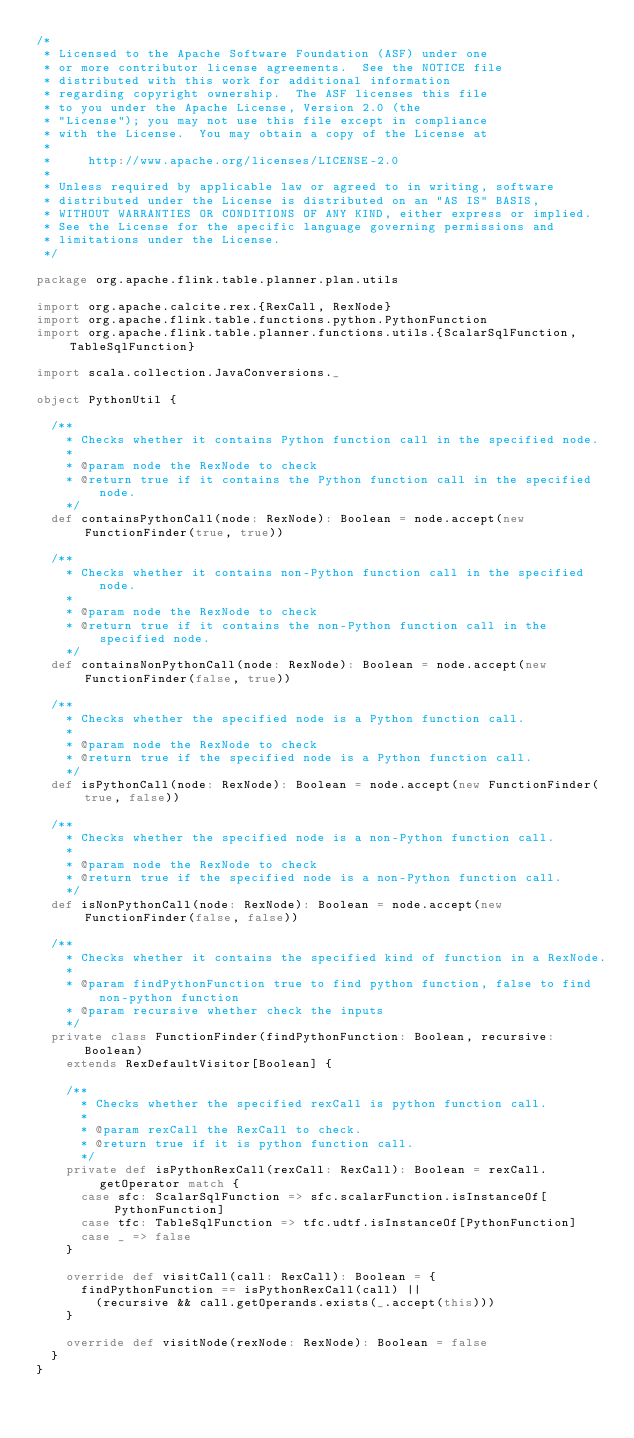<code> <loc_0><loc_0><loc_500><loc_500><_Scala_>/*
 * Licensed to the Apache Software Foundation (ASF) under one
 * or more contributor license agreements.  See the NOTICE file
 * distributed with this work for additional information
 * regarding copyright ownership.  The ASF licenses this file
 * to you under the Apache License, Version 2.0 (the
 * "License"); you may not use this file except in compliance
 * with the License.  You may obtain a copy of the License at
 *
 *     http://www.apache.org/licenses/LICENSE-2.0
 *
 * Unless required by applicable law or agreed to in writing, software
 * distributed under the License is distributed on an "AS IS" BASIS,
 * WITHOUT WARRANTIES OR CONDITIONS OF ANY KIND, either express or implied.
 * See the License for the specific language governing permissions and
 * limitations under the License.
 */

package org.apache.flink.table.planner.plan.utils

import org.apache.calcite.rex.{RexCall, RexNode}
import org.apache.flink.table.functions.python.PythonFunction
import org.apache.flink.table.planner.functions.utils.{ScalarSqlFunction, TableSqlFunction}

import scala.collection.JavaConversions._

object PythonUtil {

  /**
    * Checks whether it contains Python function call in the specified node.
    *
    * @param node the RexNode to check
    * @return true if it contains the Python function call in the specified node.
    */
  def containsPythonCall(node: RexNode): Boolean = node.accept(new FunctionFinder(true, true))

  /**
    * Checks whether it contains non-Python function call in the specified node.
    *
    * @param node the RexNode to check
    * @return true if it contains the non-Python function call in the specified node.
    */
  def containsNonPythonCall(node: RexNode): Boolean = node.accept(new FunctionFinder(false, true))

  /**
    * Checks whether the specified node is a Python function call.
    *
    * @param node the RexNode to check
    * @return true if the specified node is a Python function call.
    */
  def isPythonCall(node: RexNode): Boolean = node.accept(new FunctionFinder(true, false))

  /**
    * Checks whether the specified node is a non-Python function call.
    *
    * @param node the RexNode to check
    * @return true if the specified node is a non-Python function call.
    */
  def isNonPythonCall(node: RexNode): Boolean = node.accept(new FunctionFinder(false, false))

  /**
    * Checks whether it contains the specified kind of function in a RexNode.
    *
    * @param findPythonFunction true to find python function, false to find non-python function
    * @param recursive whether check the inputs
    */
  private class FunctionFinder(findPythonFunction: Boolean, recursive: Boolean)
    extends RexDefaultVisitor[Boolean] {

    /**
      * Checks whether the specified rexCall is python function call.
      *
      * @param rexCall the RexCall to check.
      * @return true if it is python function call.
      */
    private def isPythonRexCall(rexCall: RexCall): Boolean = rexCall.getOperator match {
      case sfc: ScalarSqlFunction => sfc.scalarFunction.isInstanceOf[PythonFunction]
      case tfc: TableSqlFunction => tfc.udtf.isInstanceOf[PythonFunction]
      case _ => false
    }

    override def visitCall(call: RexCall): Boolean = {
      findPythonFunction == isPythonRexCall(call) ||
        (recursive && call.getOperands.exists(_.accept(this)))
    }

    override def visitNode(rexNode: RexNode): Boolean = false
  }
}
</code> 